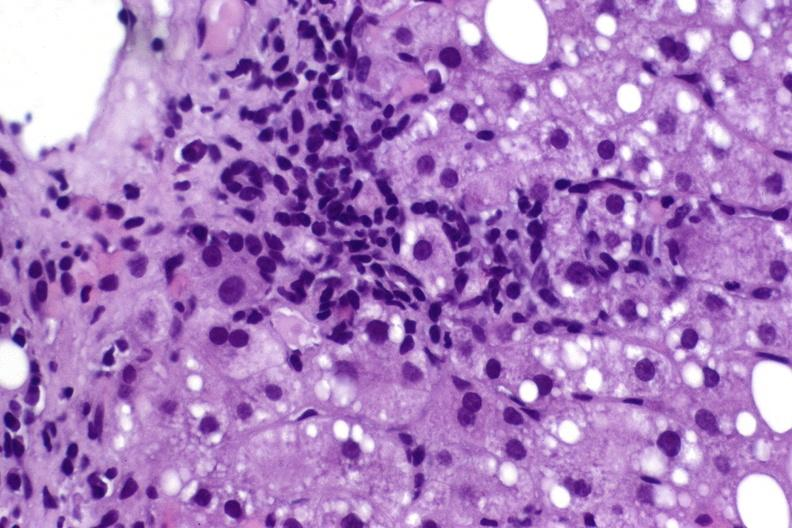s close-up tumor present?
Answer the question using a single word or phrase. No 